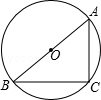Consider the same circle diagram. If angle BAC was less than 52 degrees, say 45 degrees, how would that affect the measure of angle ABC? If angle BAC were to decrease to 45 degrees, the measure of angle ABC would subsequently increase since it is calculated as 90 degrees minus angle BAC. Precisely, angle ABC would be 90 - 45 = 45 degrees. This change maintains the right triangle property, as the sum of angles in any triangle must total 180 degrees. 